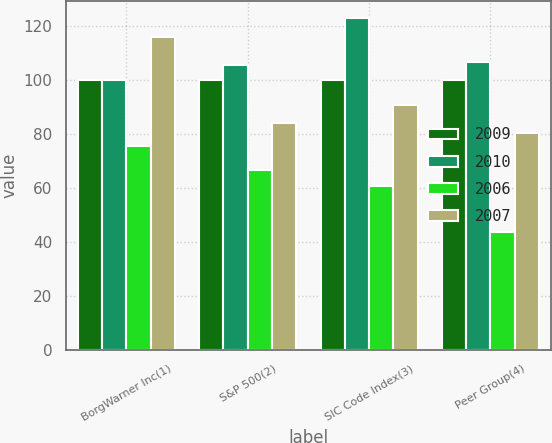Convert chart to OTSL. <chart><loc_0><loc_0><loc_500><loc_500><stacked_bar_chart><ecel><fcel>BorgWarner Inc(1)<fcel>S&P 500(2)<fcel>SIC Code Index(3)<fcel>Peer Group(4)<nl><fcel>2009<fcel>100<fcel>100<fcel>100<fcel>100<nl><fcel>2010<fcel>100<fcel>105.49<fcel>122.85<fcel>106.6<nl><fcel>2006<fcel>75.32<fcel>66.46<fcel>60.78<fcel>43.72<nl><fcel>2007<fcel>115.7<fcel>84.05<fcel>90.69<fcel>80.29<nl></chart> 